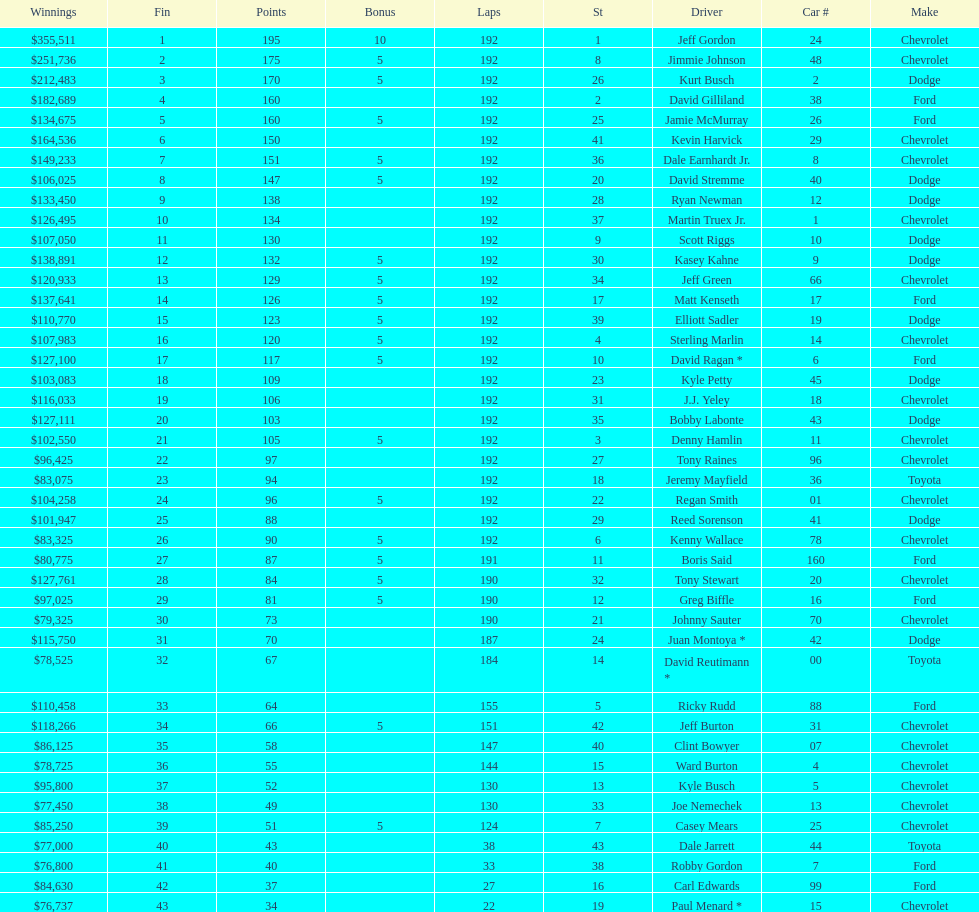Who got the most bonus points? Jeff Gordon. 